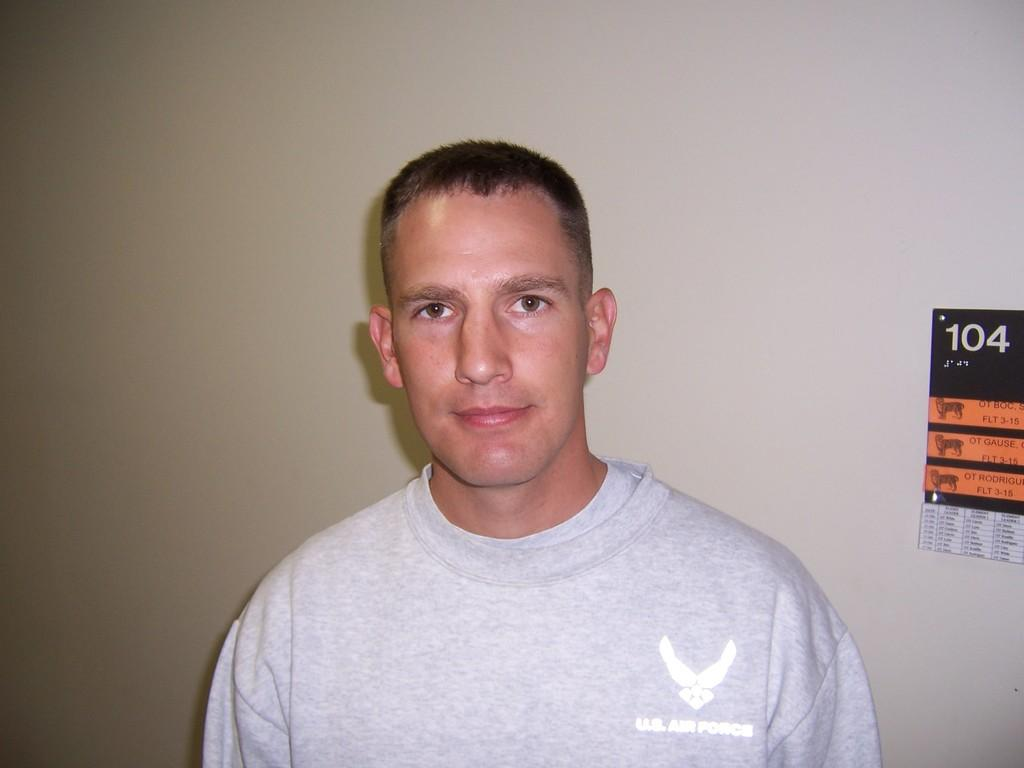Who is present in the image? There is a man in the picture. What is the man's facial expression? The man is smiling. What type of clothing is the man wearing? The man is wearing a t-shirt. What can be seen on the wall behind the man? There is a poster on the wall behind the man. What type of anger can be seen on the giraffe's face in the image? There is no giraffe present in the image, and therefore no facial expression to describe. 